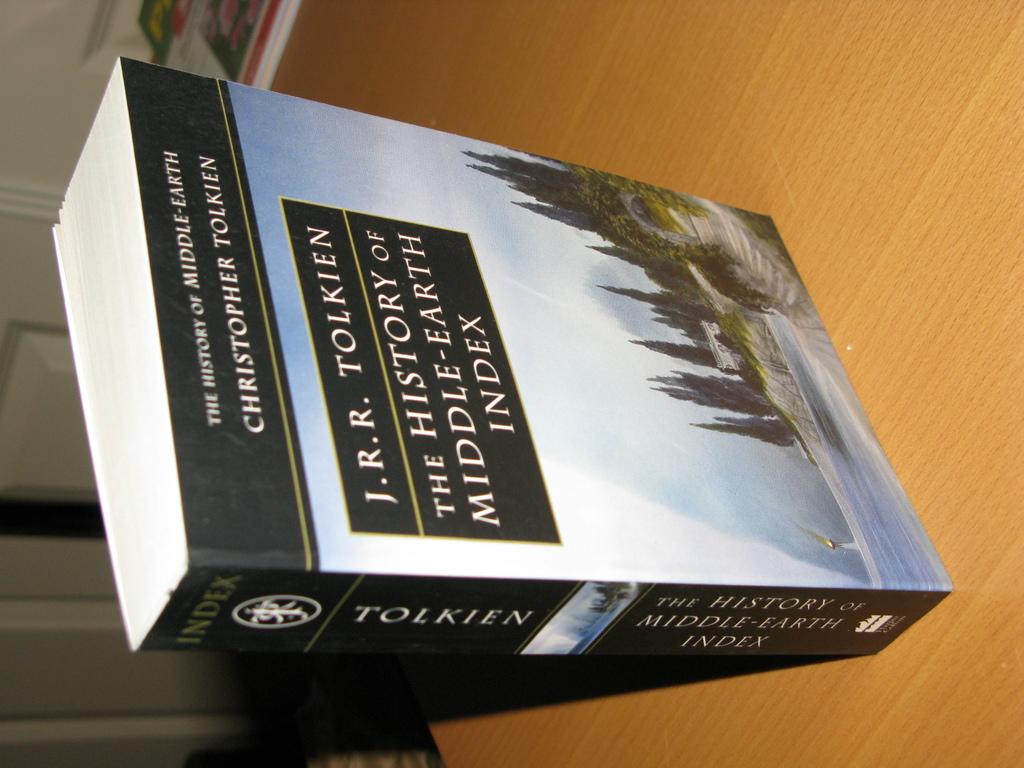What is the title of the book?
Offer a terse response. The history of middle earth index. Who is the author?
Make the answer very short. J.r.r. tolkien. 